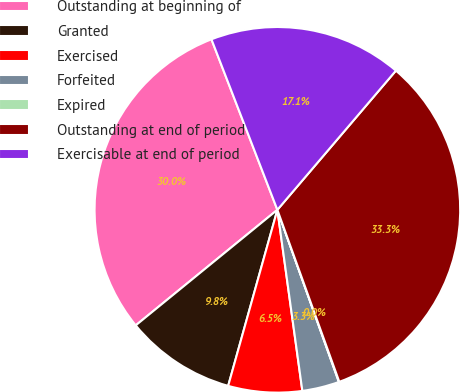Convert chart to OTSL. <chart><loc_0><loc_0><loc_500><loc_500><pie_chart><fcel>Outstanding at beginning of<fcel>Granted<fcel>Exercised<fcel>Forfeited<fcel>Expired<fcel>Outstanding at end of period<fcel>Exercisable at end of period<nl><fcel>30.02%<fcel>9.77%<fcel>6.52%<fcel>3.28%<fcel>0.04%<fcel>33.27%<fcel>17.1%<nl></chart> 